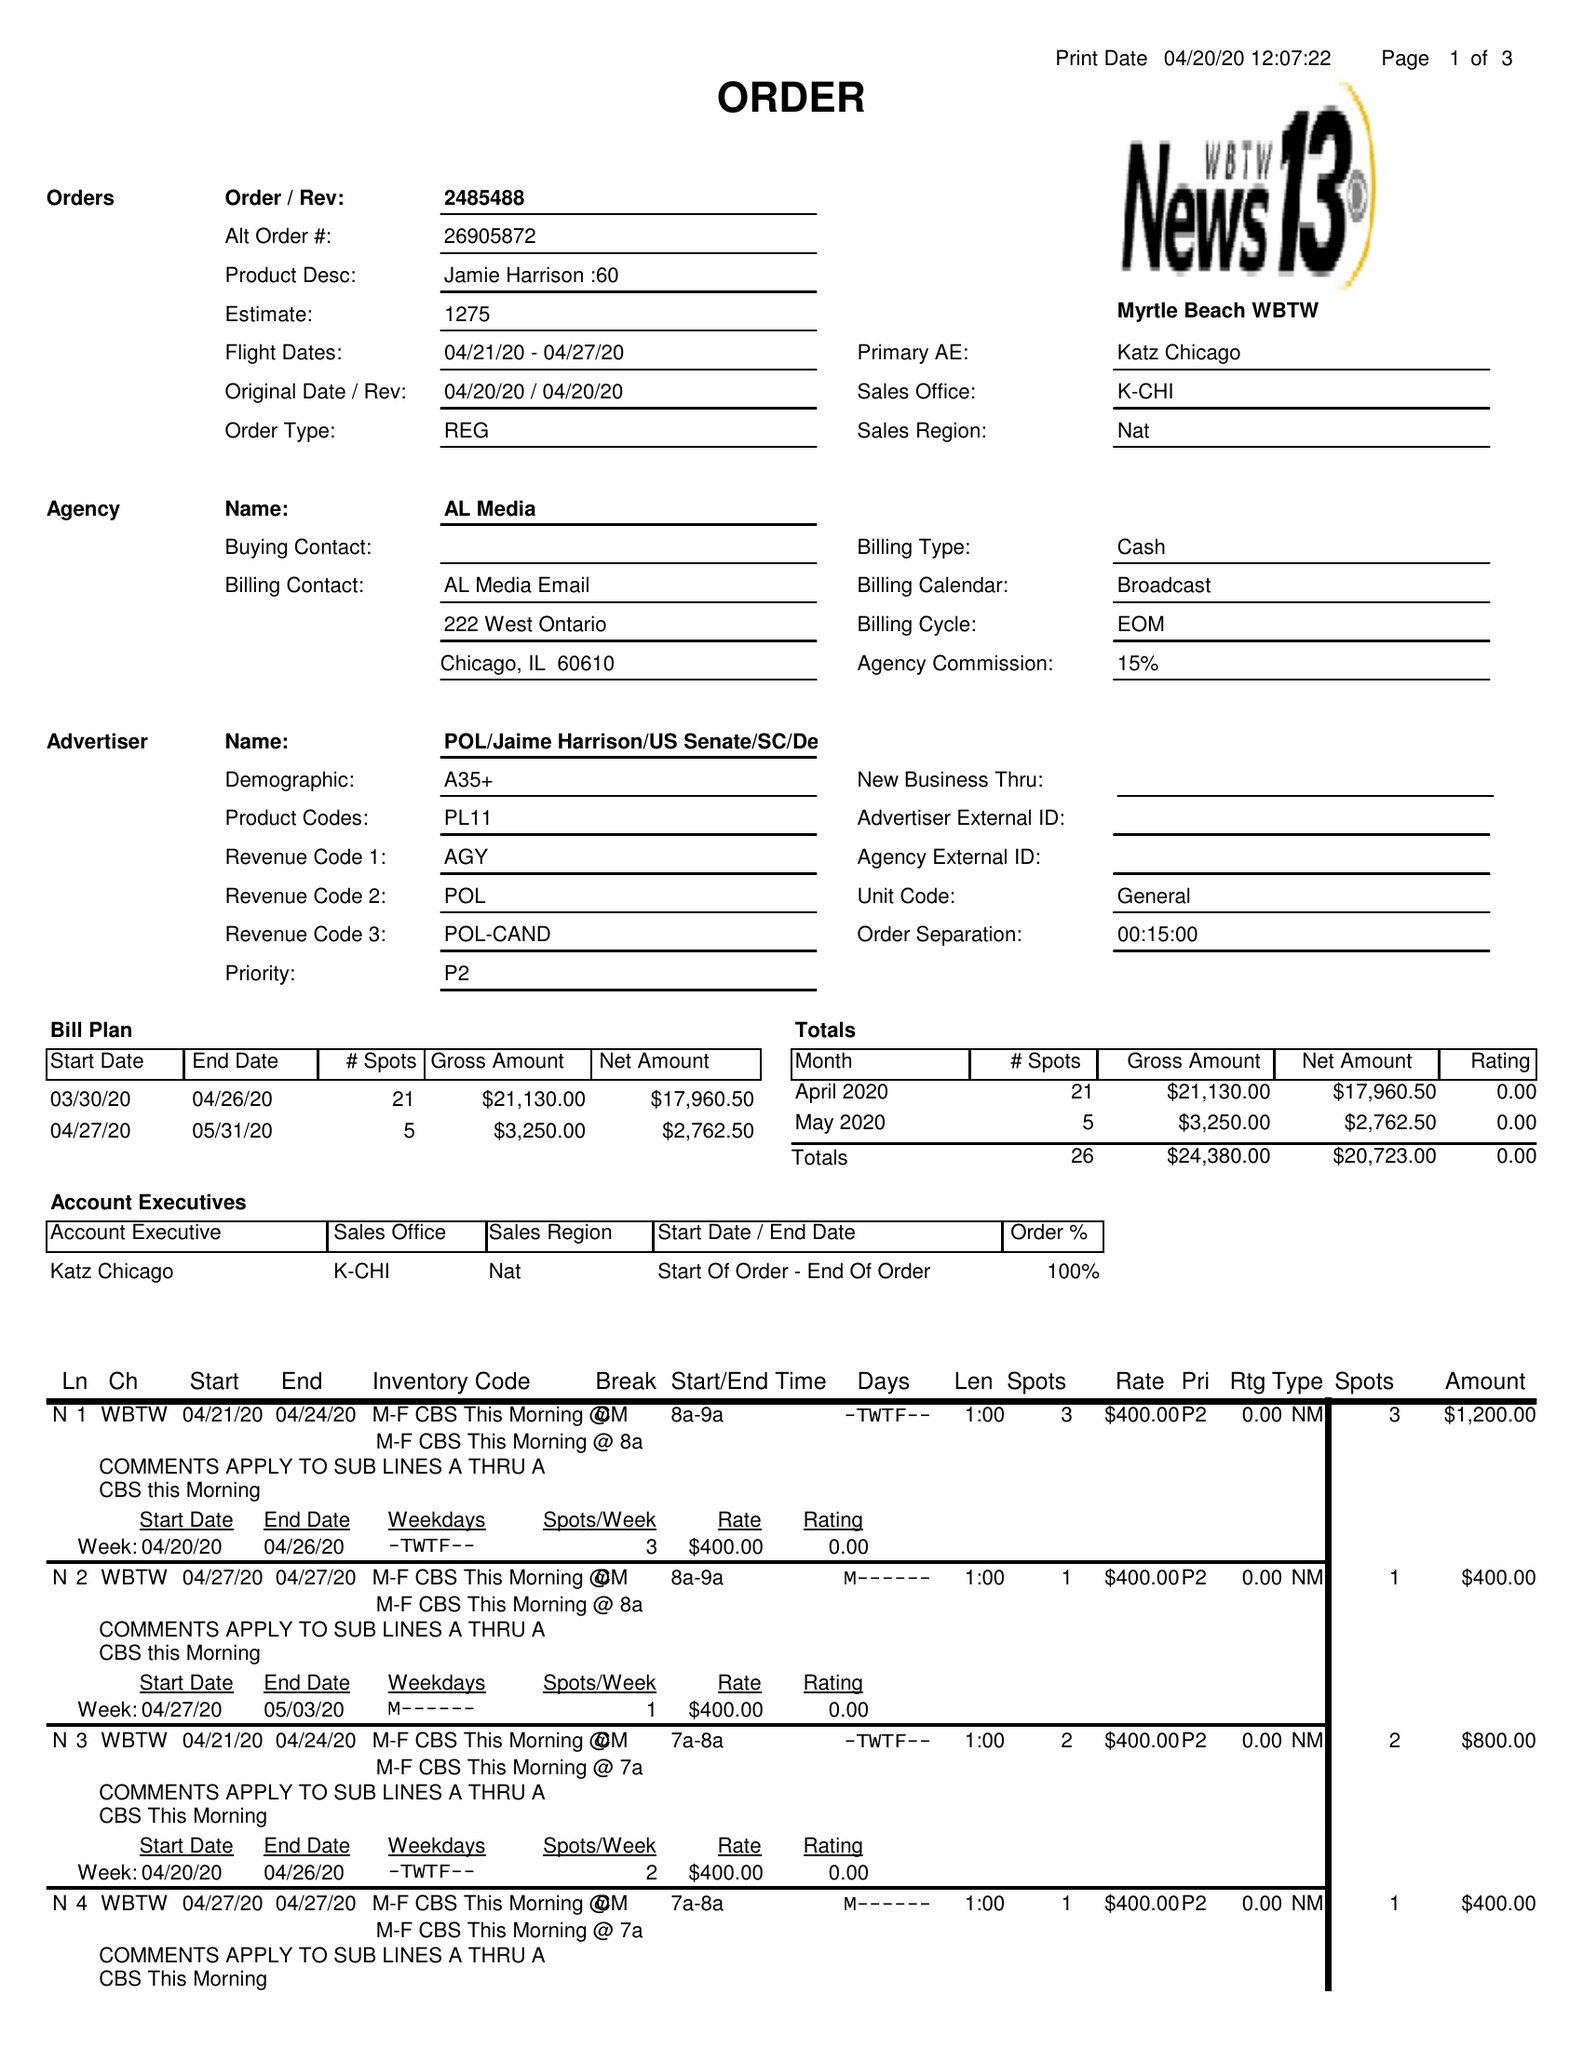What is the value for the flight_from?
Answer the question using a single word or phrase. 04/21/20 